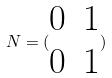<formula> <loc_0><loc_0><loc_500><loc_500>N = ( \begin{matrix} 0 & 1 \\ 0 & 1 \end{matrix} )</formula> 